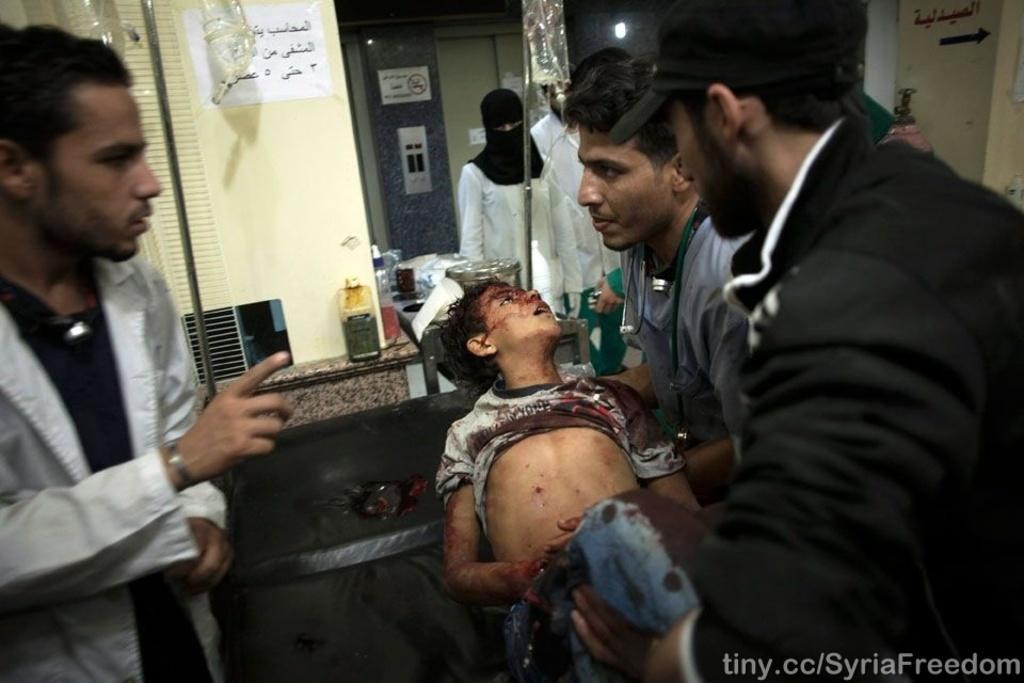Could you give a brief overview of what you see in this image? In this image we can see some group of persons standing and two men lifting up a kid in their hands who got injured and there is a black bed and in the background of the image there is a wall, elevator. 